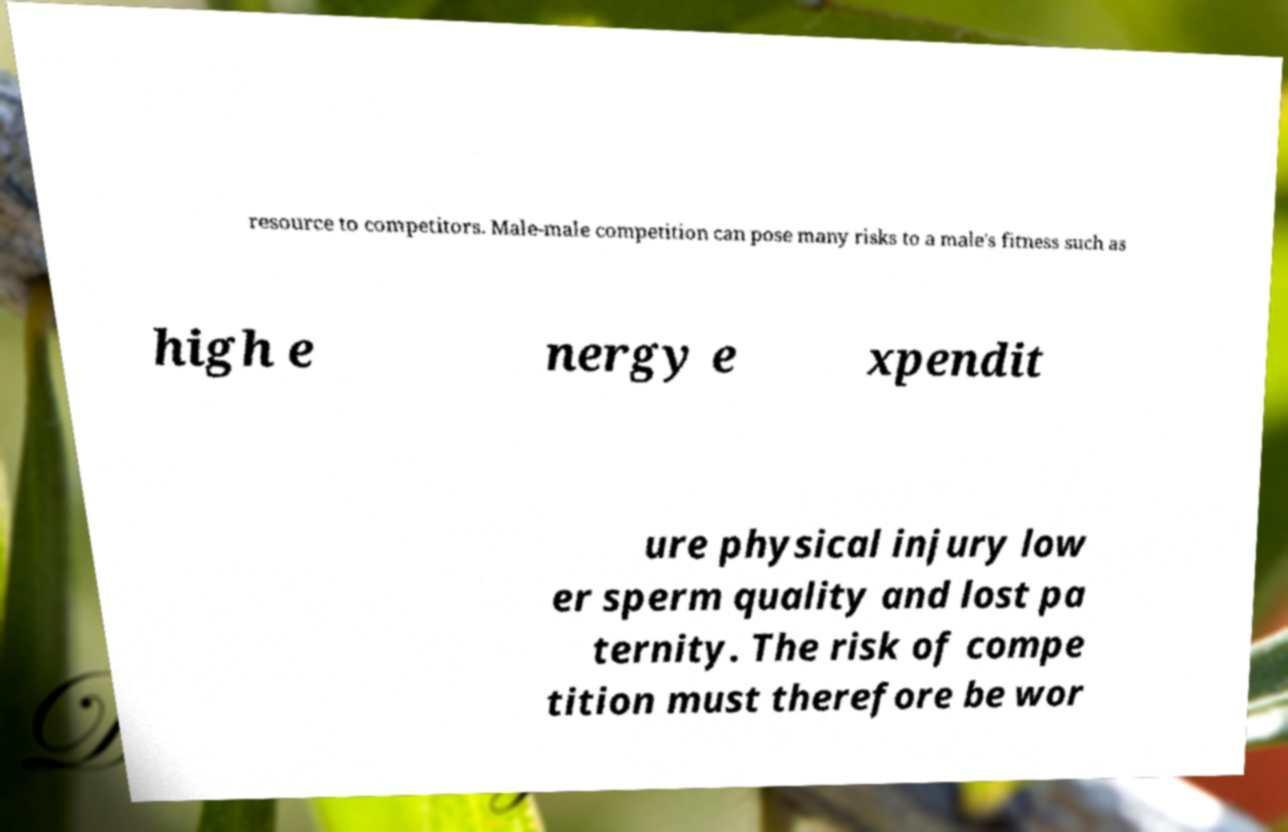Can you read and provide the text displayed in the image?This photo seems to have some interesting text. Can you extract and type it out for me? resource to competitors. Male-male competition can pose many risks to a male's fitness such as high e nergy e xpendit ure physical injury low er sperm quality and lost pa ternity. The risk of compe tition must therefore be wor 